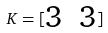<formula> <loc_0><loc_0><loc_500><loc_500>K = [ \begin{matrix} 3 & 3 \end{matrix} ]</formula> 